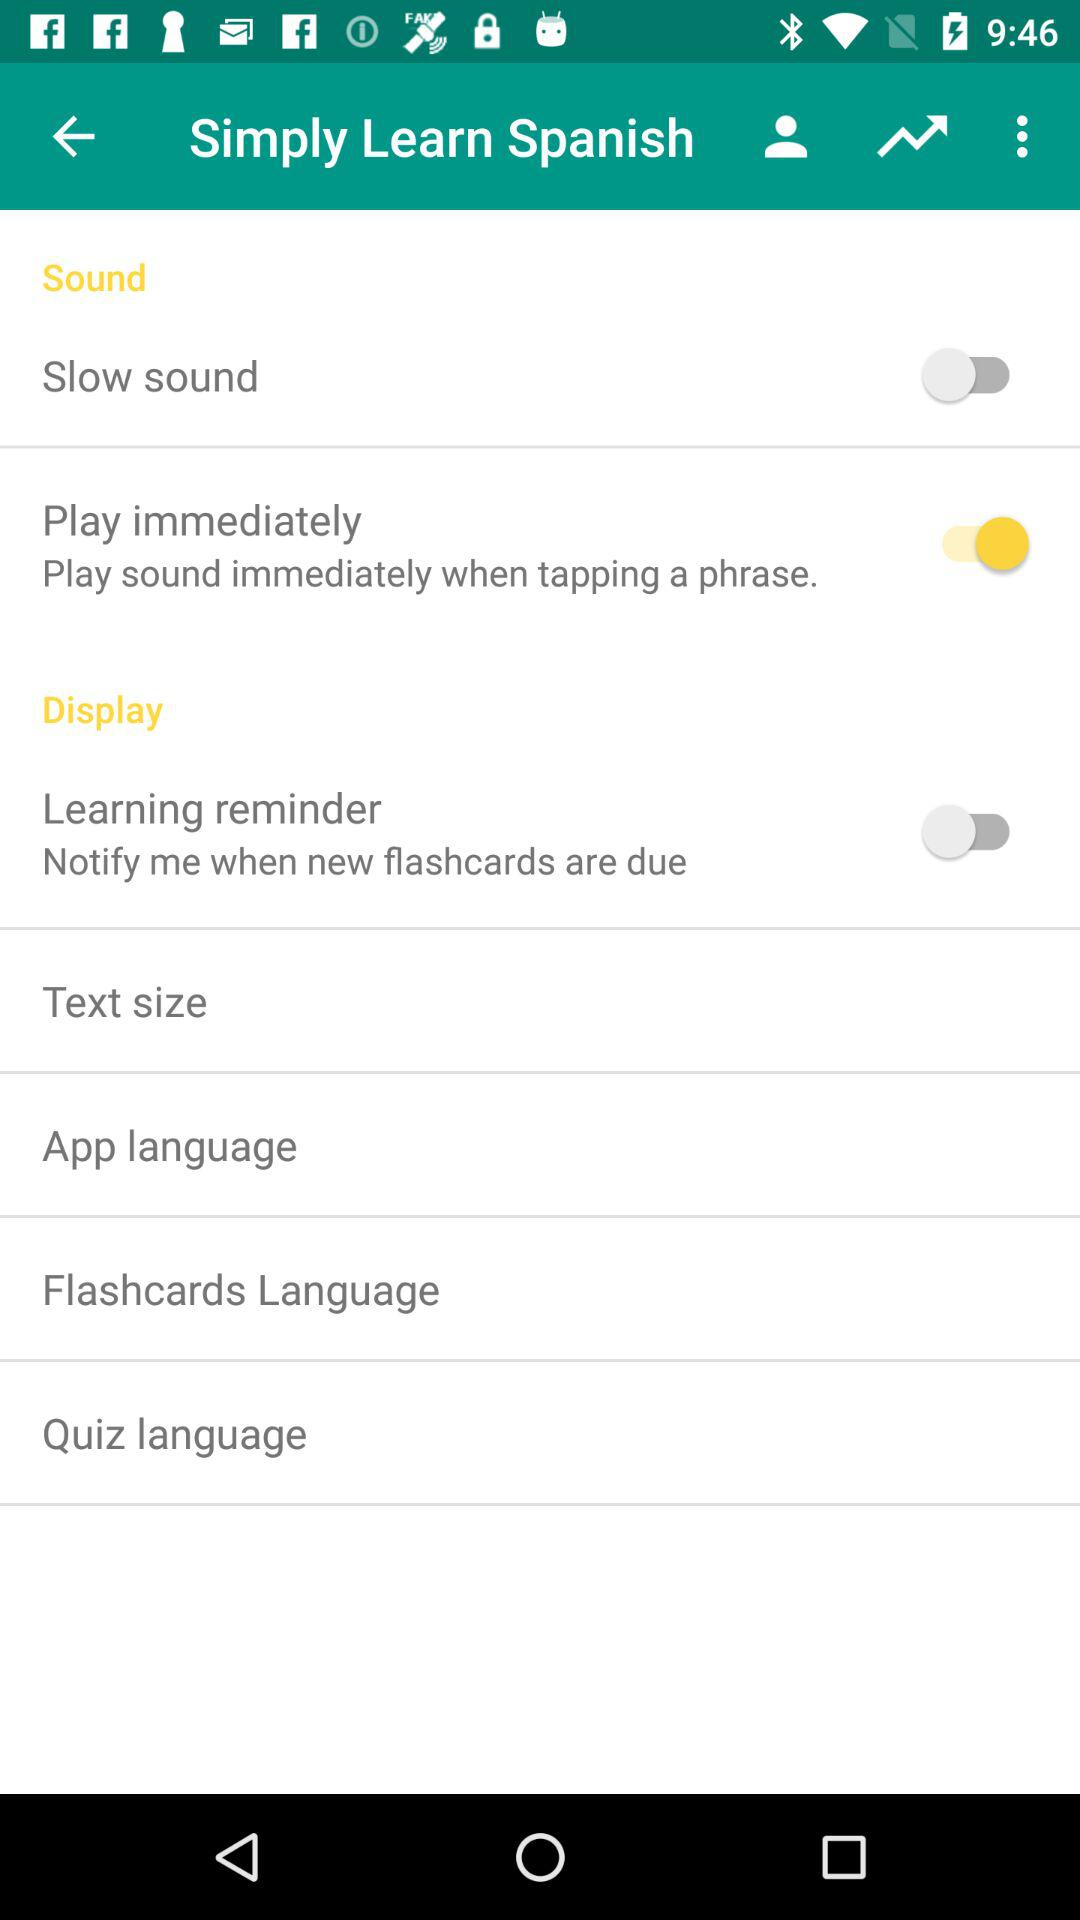What is the status of the "Slow sound"? The status is "off". 